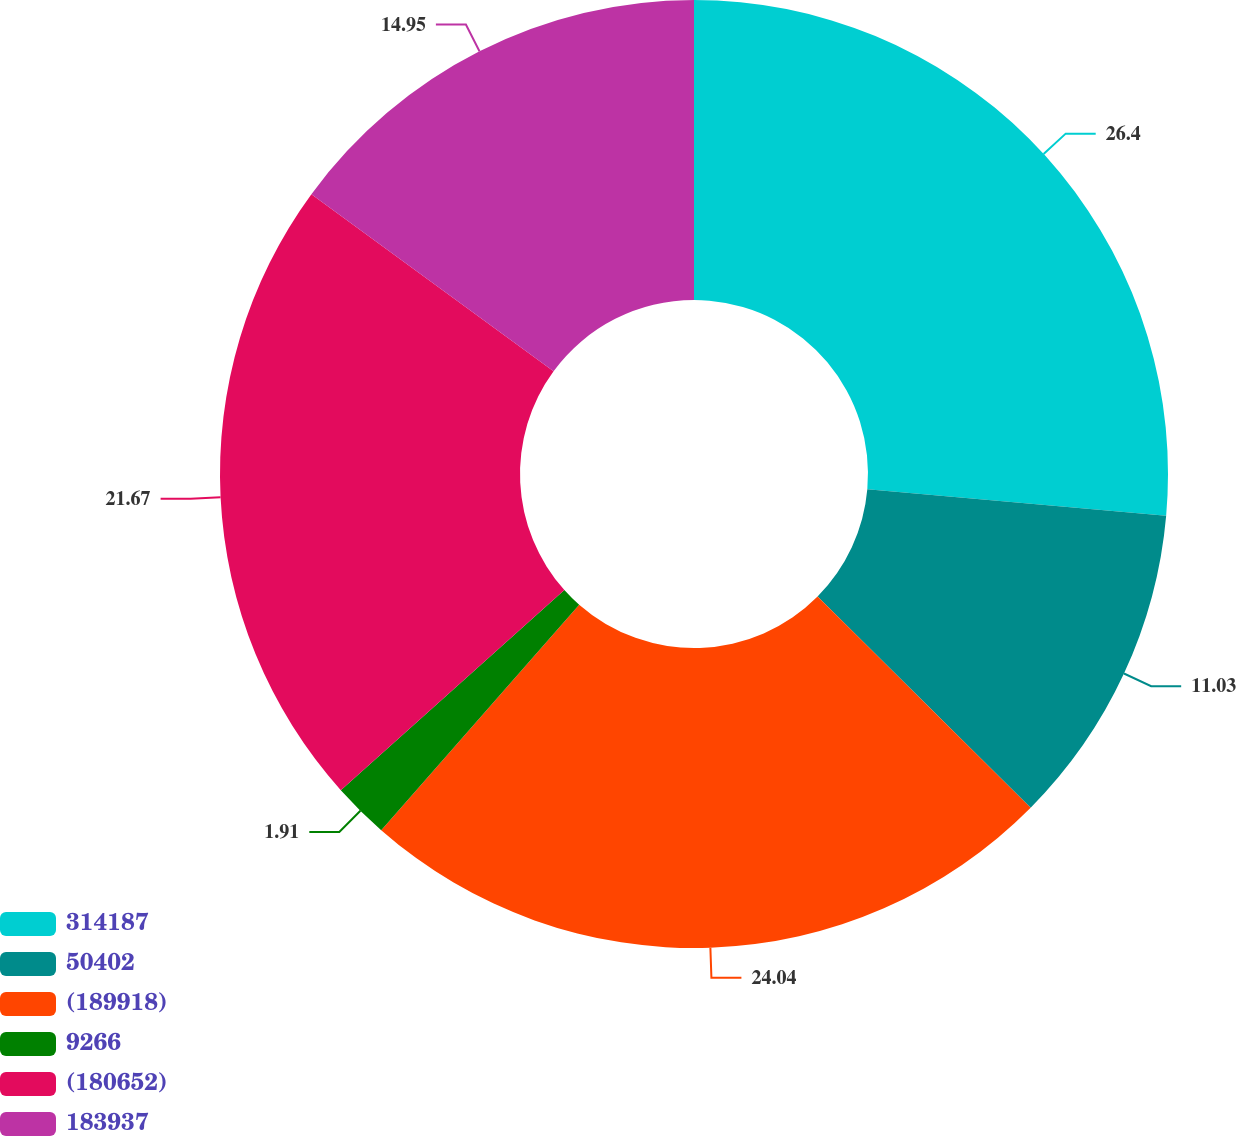Convert chart to OTSL. <chart><loc_0><loc_0><loc_500><loc_500><pie_chart><fcel>314187<fcel>50402<fcel>(189918)<fcel>9266<fcel>(180652)<fcel>183937<nl><fcel>26.4%<fcel>11.03%<fcel>24.04%<fcel>1.91%<fcel>21.67%<fcel>14.95%<nl></chart> 